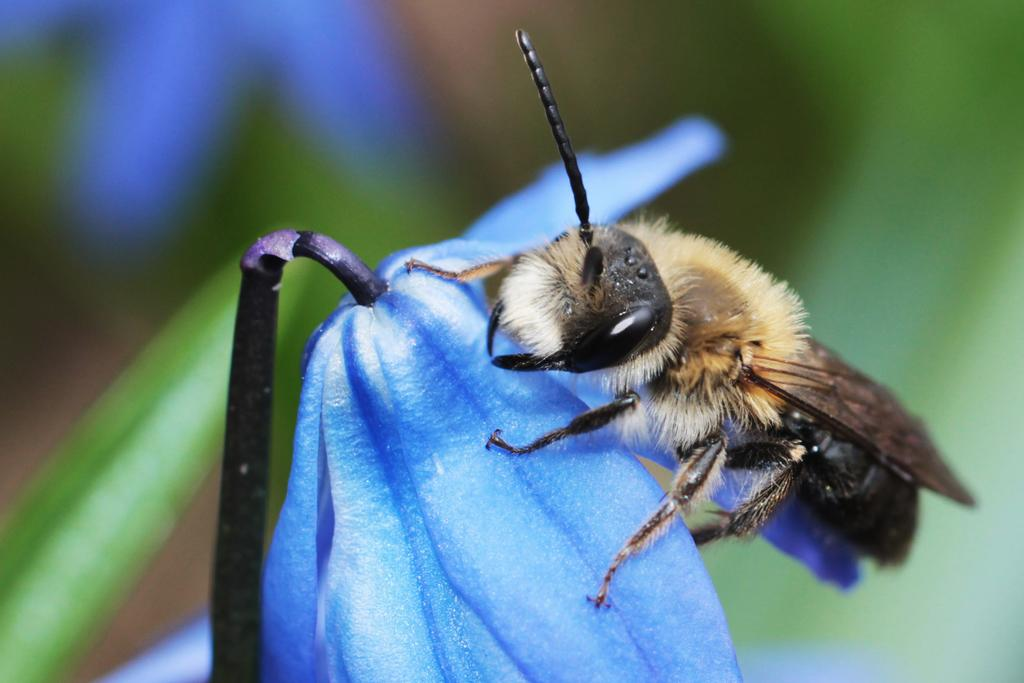What is in the foreground of the picture? There is a honey bee and a flower in the foreground of the picture. What is the honey bee interacting with in the picture? The honey bee is interacting with the flower in the foreground of the picture. What can be seen in the background of the picture? There is greenery visible in the background of the picture. What type of quartz can be seen in the picture? There is no quartz present in the picture; it features a honey bee and a flower in the foreground and greenery in the background. 